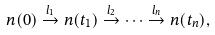<formula> <loc_0><loc_0><loc_500><loc_500>n ( 0 ) \stackrel { l _ { 1 } } { \rightarrow } n ( t _ { 1 } ) \stackrel { l _ { 2 } } { \rightarrow } \cdots \stackrel { l _ { n } } { \rightarrow } n ( t _ { n } ) ,</formula> 